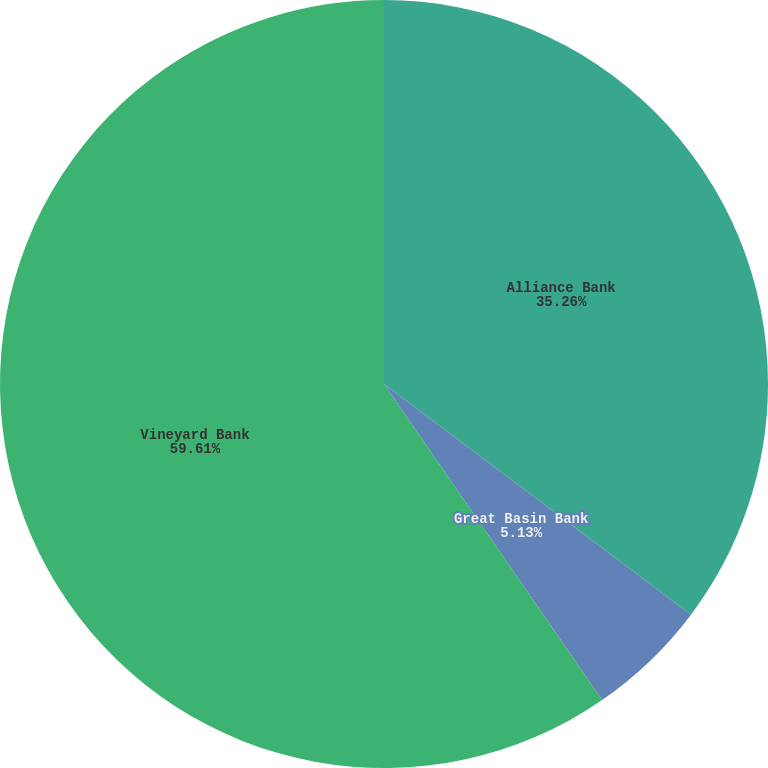Convert chart. <chart><loc_0><loc_0><loc_500><loc_500><pie_chart><fcel>Alliance Bank<fcel>Great Basin Bank<fcel>Vineyard Bank<nl><fcel>35.26%<fcel>5.13%<fcel>59.62%<nl></chart> 